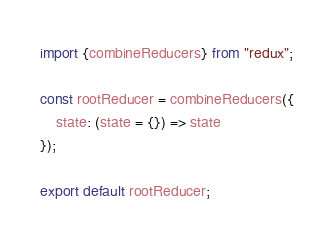<code> <loc_0><loc_0><loc_500><loc_500><_JavaScript_>import {combineReducers} from "redux";

const rootReducer = combineReducers({
	state: (state = {}) => state
});

export default rootReducer;</code> 